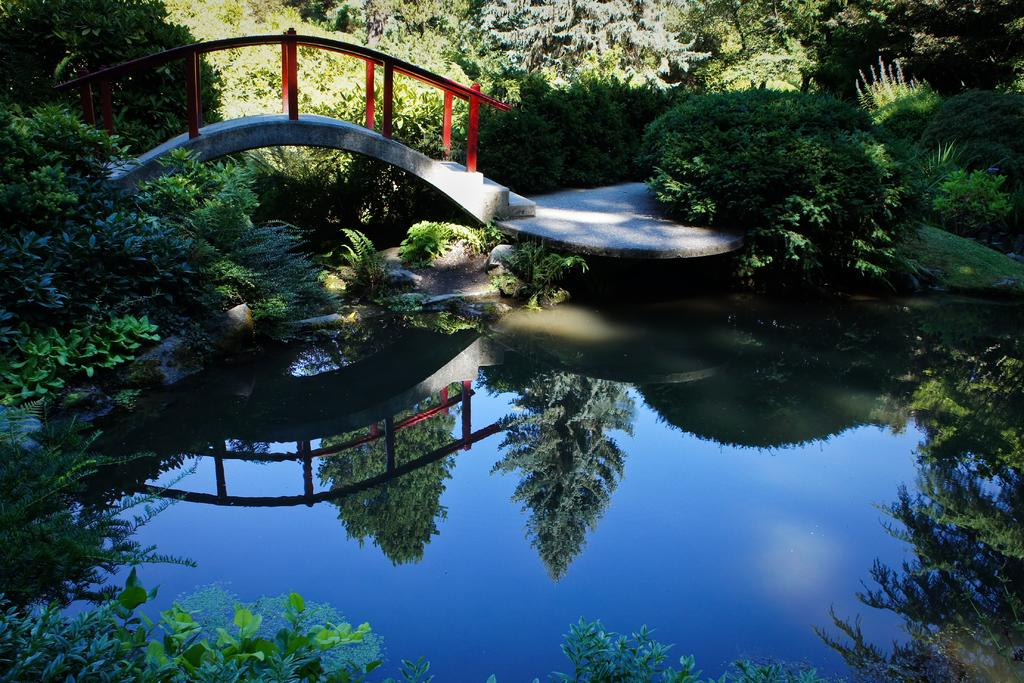What is present in the front of the image? There is water in the front of the image. What can be found floating in the water? There are leaves in the water. What is located in the center of the image? There are plants and a bridge in the center of the image. What type of vegetation is visible in the background of the image? There are trees in the background of the background of the image. Where is the pen placed on the desk in the image? There is no pen or desk present in the image. What trick is being performed with the leaves in the water? There is no trick being performed in the image; the leaves are simply floating in the water. 